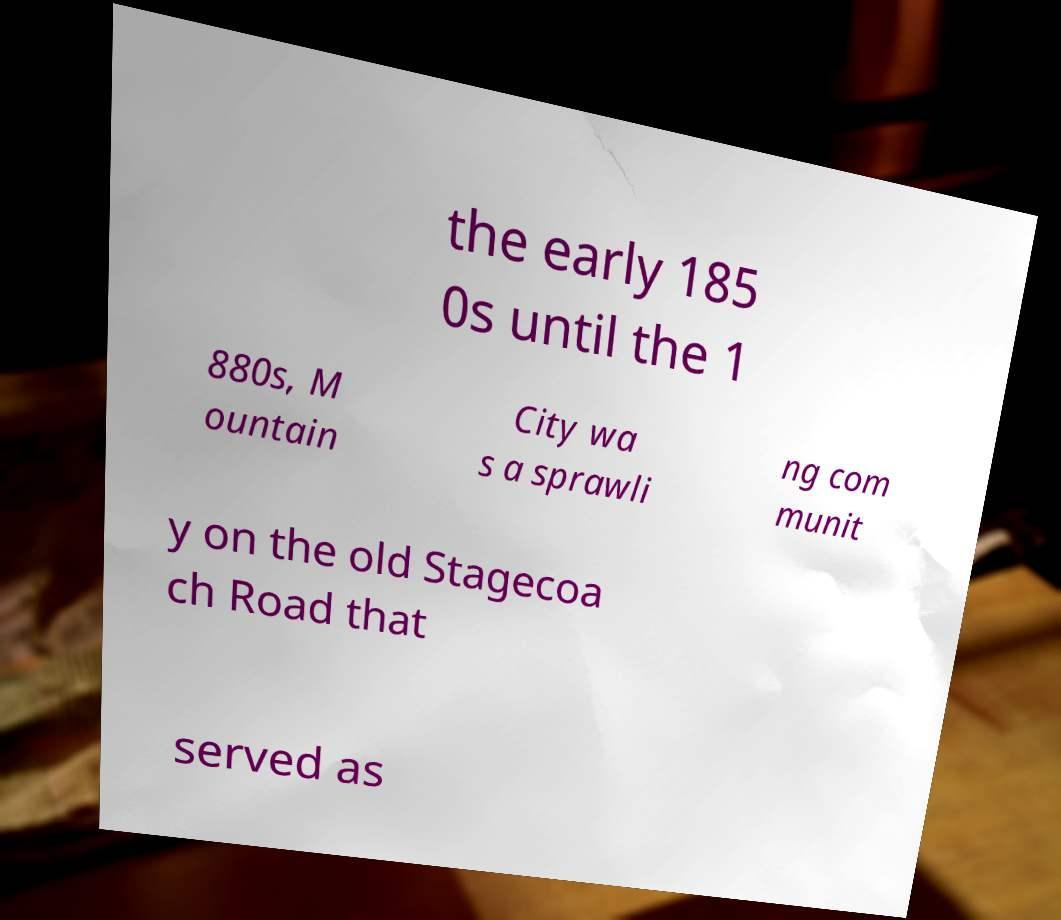Could you assist in decoding the text presented in this image and type it out clearly? the early 185 0s until the 1 880s, M ountain City wa s a sprawli ng com munit y on the old Stagecoa ch Road that served as 